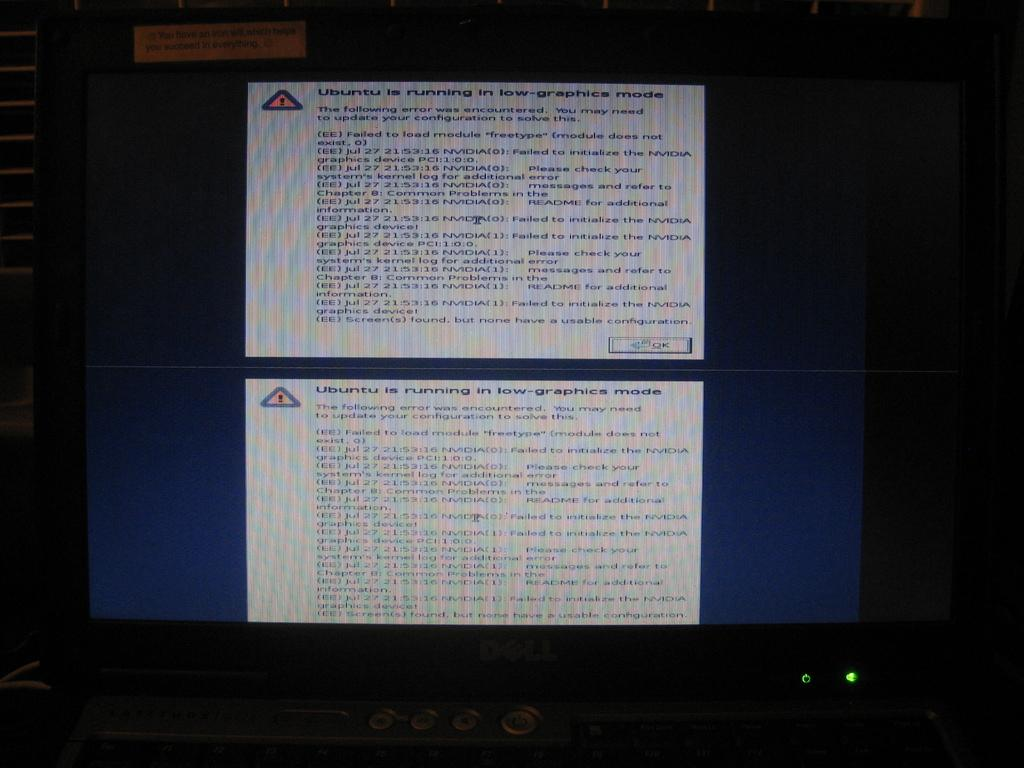Provide a one-sentence caption for the provided image. Computer screen displaying an error that Ubuntu is running in low-graphics mode. 